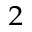Convert formula to latex. <formula><loc_0><loc_0><loc_500><loc_500>^ { 2 }</formula> 